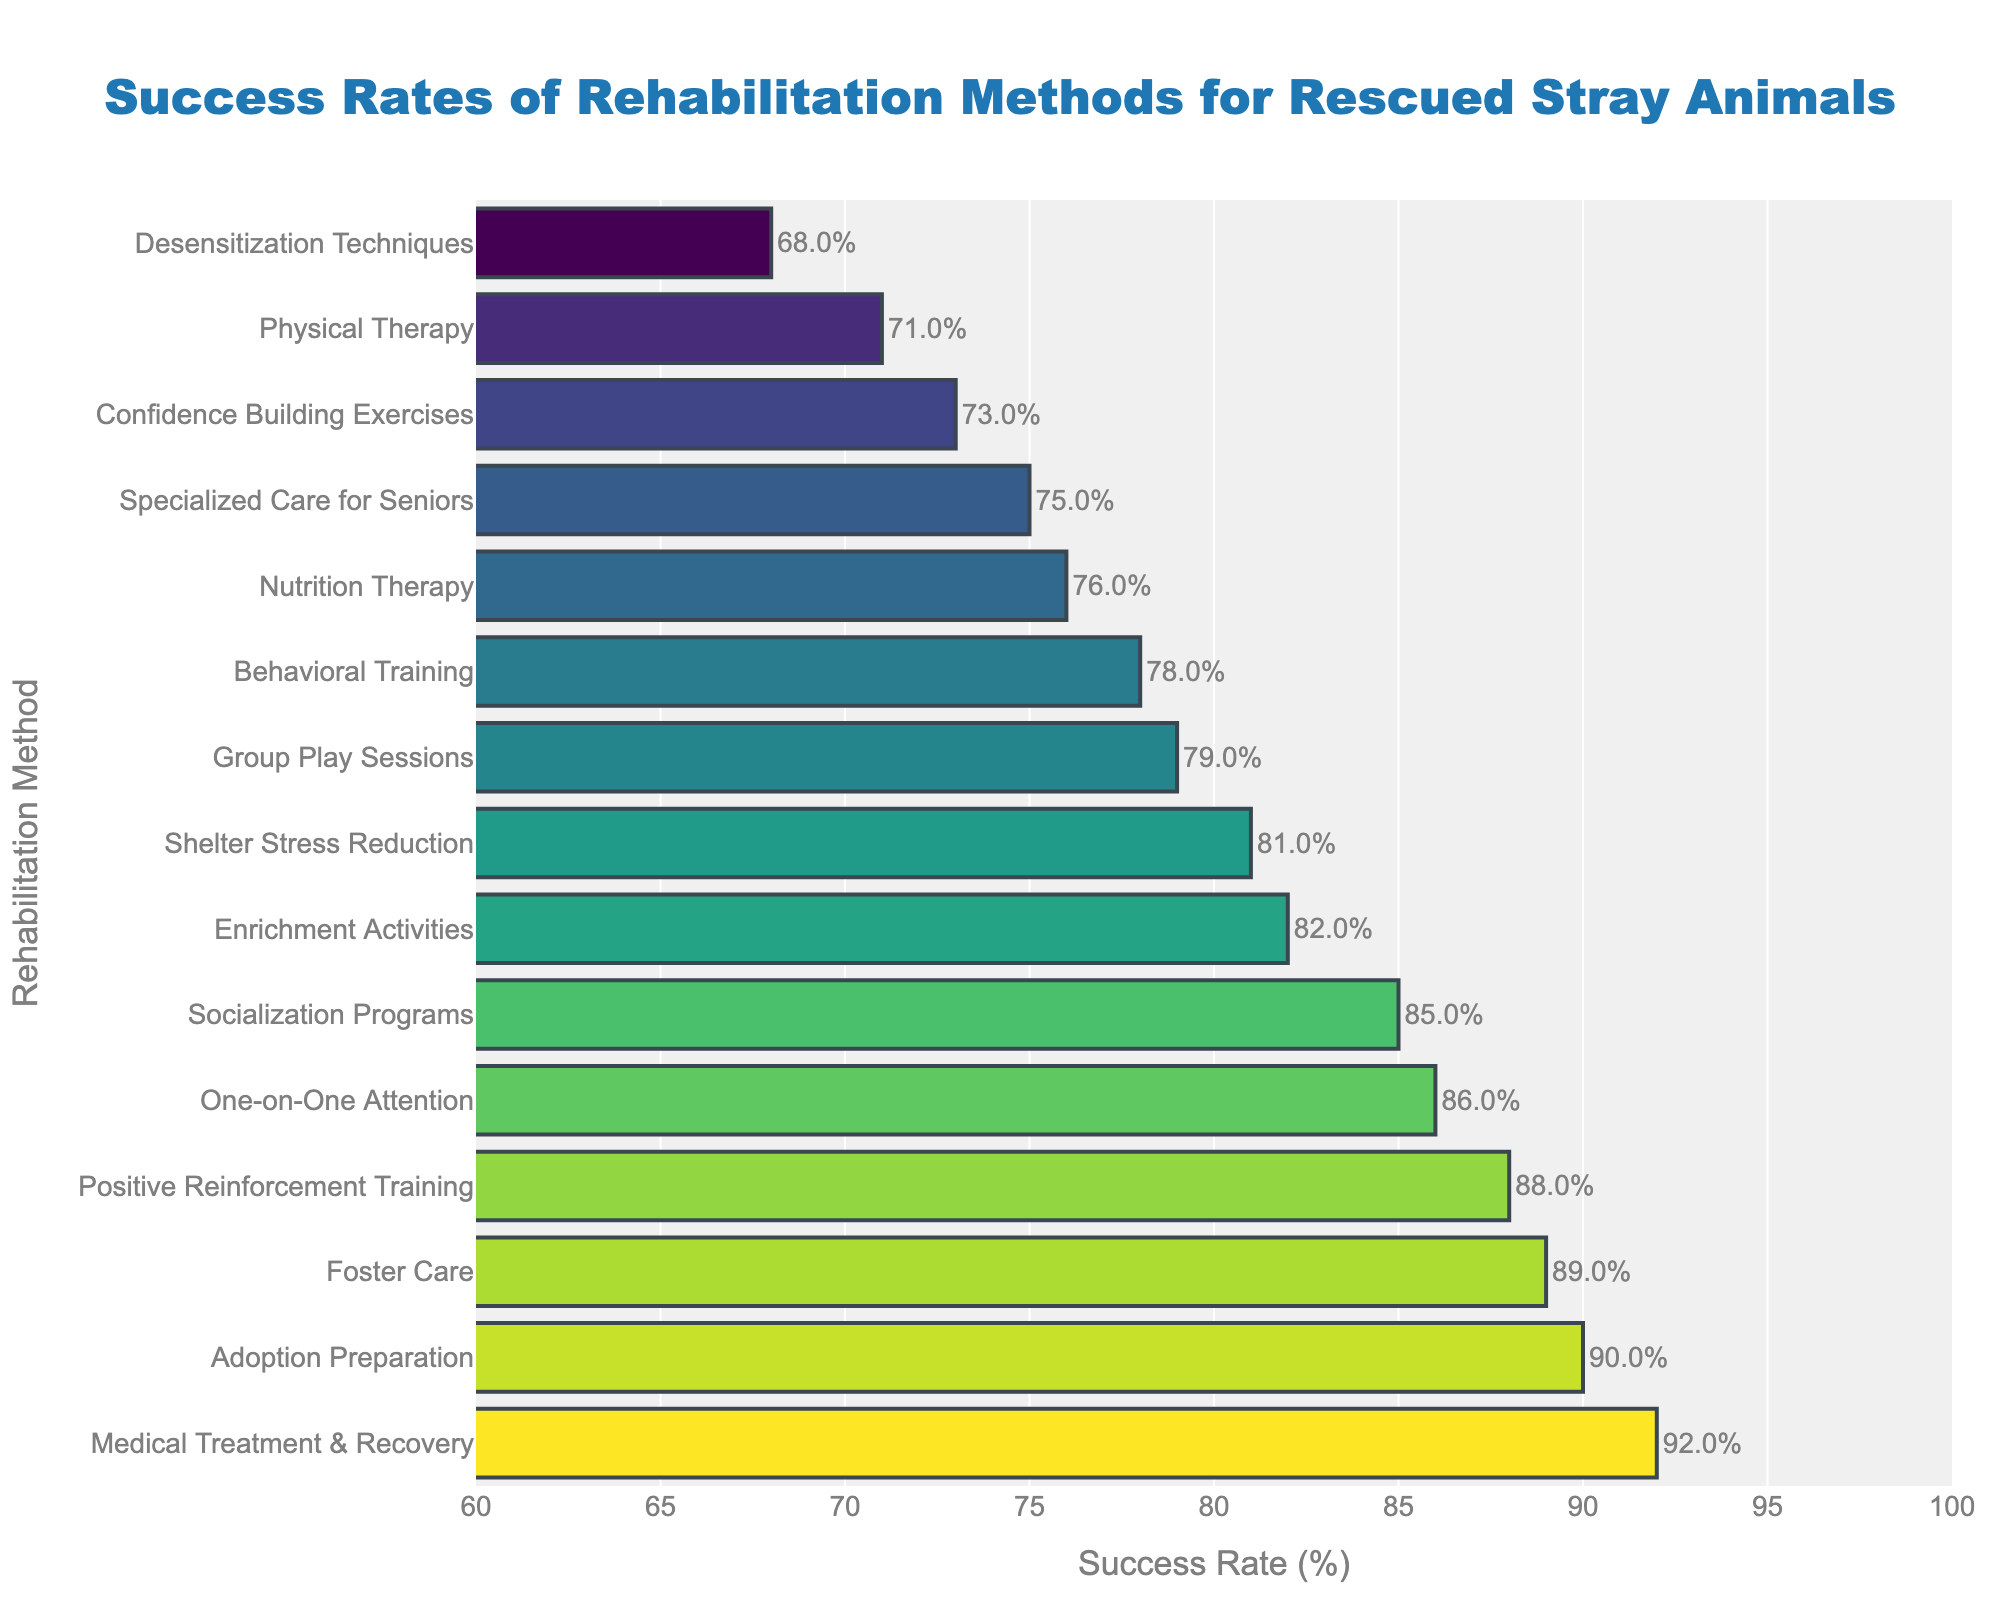Which rehabilitation method has the highest success rate? The highest bar in the figure corresponds to the method "Medical Treatment & Recovery," which reaches up to 92%.
Answer: Medical Treatment & Recovery Which method has a higher success rate: Foster Care or Group Play Sessions? By comparing the bars, Foster Care has a success rate of 89%, while Group Play Sessions have a success rate of 79%. Foster Care is higher.
Answer: Foster Care What is the difference in success rates between Positive Reinforcement Training and Desensitization Techniques? Positive Reinforcement Training has a success rate of 88%, and Desensitization Techniques have a success rate of 68%. The difference is 88% - 68% = 20%.
Answer: 20% What is the median success rate of all the rehabilitation methods? To find the median, arrange the success rates in ascending order and find the middle value. The sorted values are: 68, 71, 73, 75, 76, 78, 79, 81, 82, 85, 86, 88, 89, 90, 92. The median is the middle value, which is the 8th value in this sorted list, 81.
Answer: 81 Among the methods with success rates above 85%, which has the lowest success rate? The methods with success rates above 85% are Positive Reinforcement Training, One-on-One Attention, Foster Care, Socialization Programs, Adoption Preparation, and Medical Treatment & Recovery. Among these, the lowest is Socialization Programs at 85%.
Answer: Socialization Programs What is the average success rate of the four methods with the highest success rates? The four highest success rates are 92%, 90%, 89%, and 88%. The average is calculated as (92 + 90 + 89 + 88) / 4 = 359 / 4 = 89.75
Answer: 89.75 Identify the color pattern used for the highest success rate method. The figure shows a gradient color scale (Viridis). The bar representing the highest success rate (Medical Treatment & Recovery) would bear the lightest color representing the highest value on the Viridis scale.
Answer: Lightest color How many methods have success rates below 75%? Reviewing the figure, the bars corresponding to Desensitization Techniques (68%), Physical Therapy (71%), Confidence Building Exercises (73%), and Specialized Care for Seniors (75%) fall into this range, totalling four methods.
Answer: 4 If you combine the success rates of Nutrition Therapy and Shelter Stress Reduction, what is the combined rate? The success rates are Nutrition Therapy at 76% and Shelter Stress Reduction at 81%. The combined rate is 76 + 81 = 157%.
Answer: 157% Which method has the closest success rate to the average success rate of all methods? First, sum all success rates: 78 + 92 + 85 + 89 + 82 + 76 + 71 + 68 + 88 + 79 + 86 + 73 + 81 + 90 + 75 = 1223. The average is 1223 / 15 ≈ 81.53. The closest method to this average is Shelter Stress Reduction at 81%.
Answer: Shelter Stress Reduction 